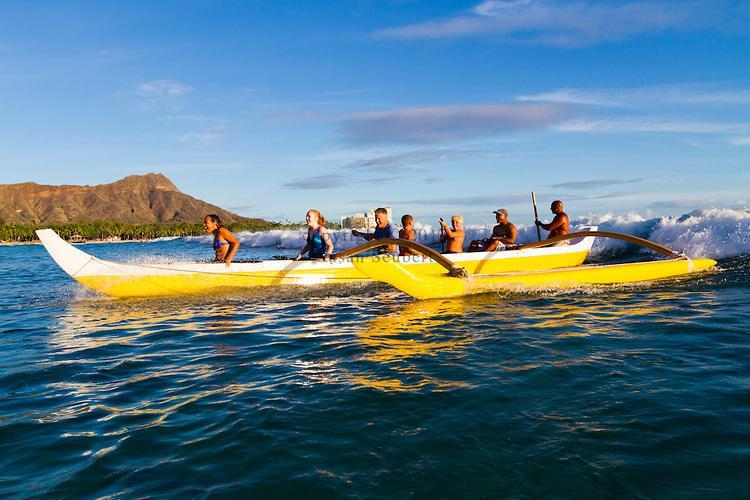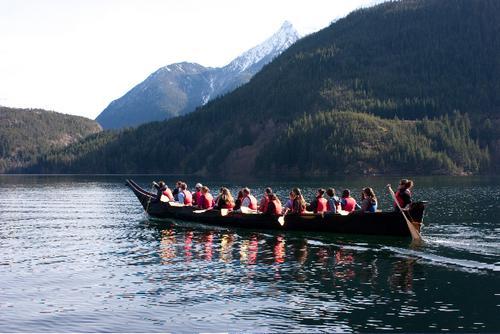The first image is the image on the left, the second image is the image on the right. Assess this claim about the two images: "An image shows just one bright yellow watercraft with riders.". Correct or not? Answer yes or no. Yes. 